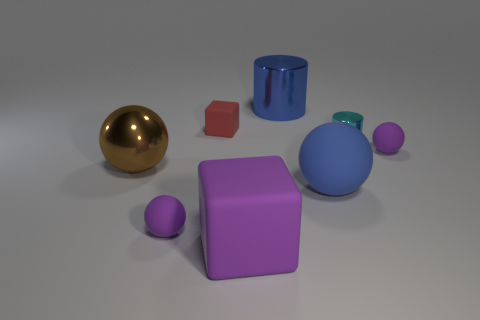The purple matte thing that is left of the tiny shiny cylinder and behind the large block has what shape?
Your answer should be very brief. Sphere. Do the large purple object and the cylinder in front of the large blue metallic cylinder have the same material?
Make the answer very short. No. There is a blue cylinder; are there any small rubber spheres on the left side of it?
Your answer should be very brief. Yes. How many objects are either cyan cylinders or small things that are right of the tiny block?
Offer a very short reply. 2. There is a large ball on the right side of the large shiny object on the right side of the brown metal object; what is its color?
Provide a succinct answer. Blue. What number of other objects are there of the same material as the red cube?
Keep it short and to the point. 4. What number of metal objects are tiny cyan things or big blocks?
Ensure brevity in your answer.  1. There is another thing that is the same shape as the blue metallic object; what color is it?
Provide a succinct answer. Cyan. What number of things are either spheres or big green rubber objects?
Provide a short and direct response. 4. What is the shape of the large thing that is the same material as the large purple block?
Your response must be concise. Sphere. 